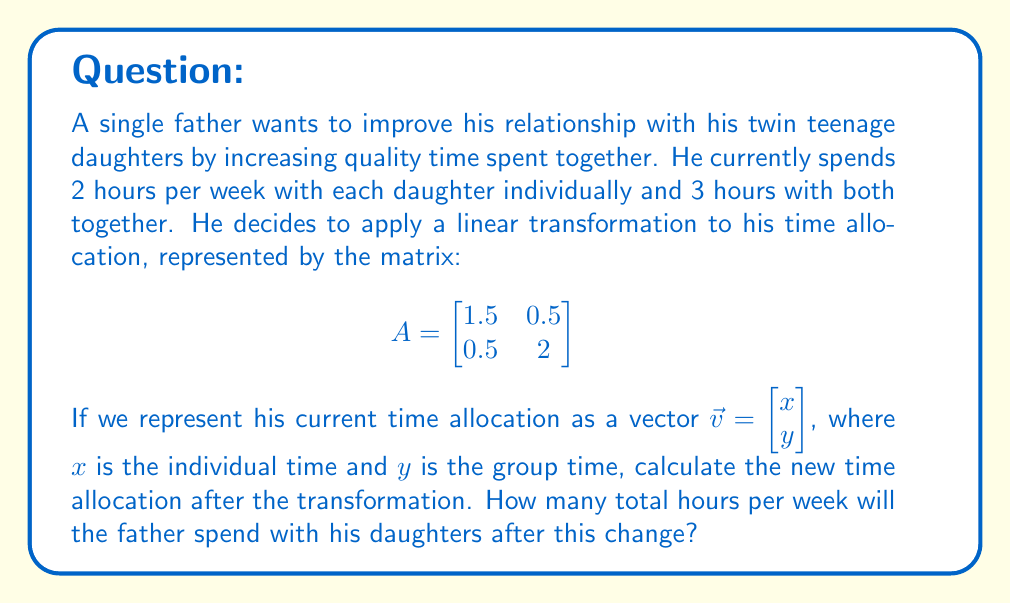Teach me how to tackle this problem. Let's approach this step-by-step:

1) First, we need to represent the current time allocation as a vector:
   $\vec{v} = \begin{bmatrix} 2 \\ 3 \end{bmatrix}$

2) To find the new time allocation, we need to multiply the transformation matrix A by the vector $\vec{v}$:

   $$A\vec{v} = \begin{bmatrix}
   1.5 & 0.5 \\
   0.5 & 2
   \end{bmatrix} \begin{bmatrix} 2 \\ 3 \end{bmatrix}$$

3) Let's perform the matrix multiplication:

   $$\begin{bmatrix}
   (1.5 \times 2) + (0.5 \times 3) \\
   (0.5 \times 2) + (2 \times 3)
   \end{bmatrix}$$

4) Calculating each element:

   $$\begin{bmatrix}
   3 + 1.5 \\
   1 + 6
   \end{bmatrix} = \begin{bmatrix}
   4.5 \\
   7
   \end{bmatrix}$$

5) This new vector represents the transformed time allocation:
   - 4.5 hours per week with each daughter individually
   - 7 hours per week with both daughters together

6) To find the total time spent:
   - Individual time: $4.5 \times 2$ (because there are two daughters) = 9 hours
   - Group time: 7 hours
   - Total: $9 + 7 = 16$ hours

Therefore, after the transformation, the father will spend a total of 16 hours per week with his daughters.
Answer: 16 hours 